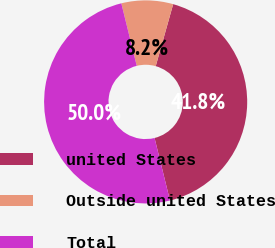Convert chart. <chart><loc_0><loc_0><loc_500><loc_500><pie_chart><fcel>united States<fcel>Outside united States<fcel>Total<nl><fcel>41.78%<fcel>8.22%<fcel>50.0%<nl></chart> 